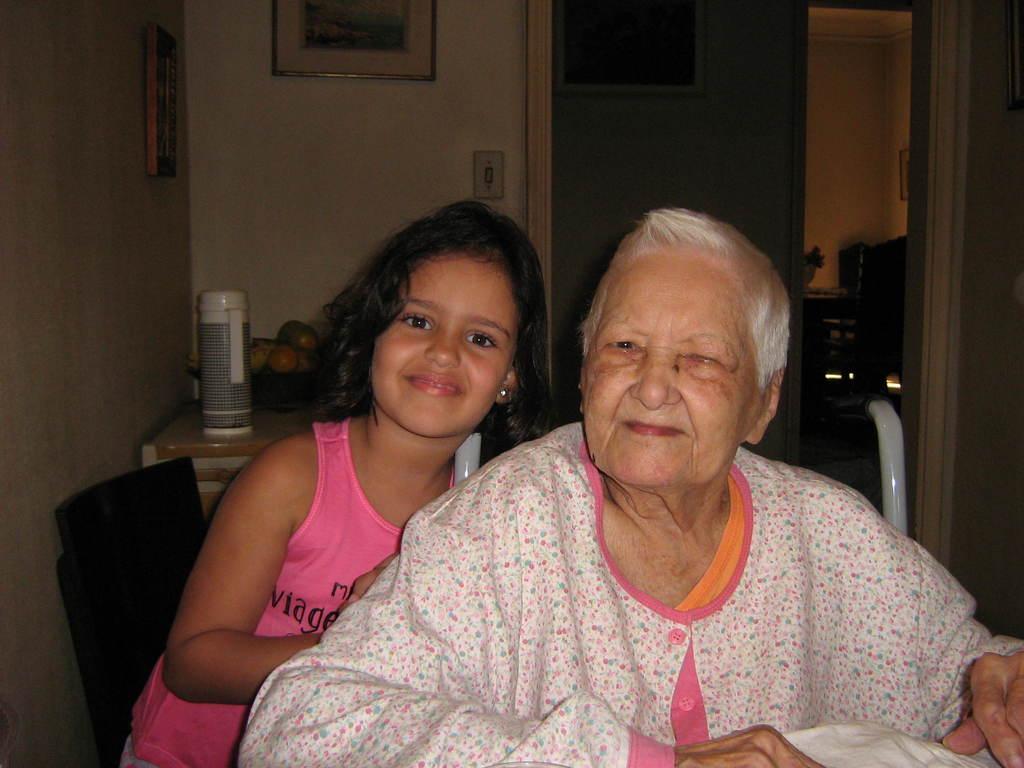Can you describe this image briefly? There is a old lady and girl. In the back there is a wall with photo frames. Also there is a table. On the table there is a flask and a bowl with fruits. 